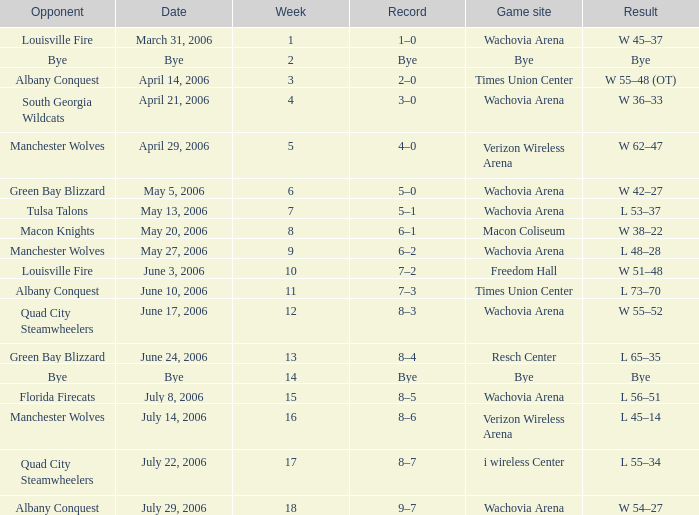What is the Game site week 1? Wachovia Arena. 